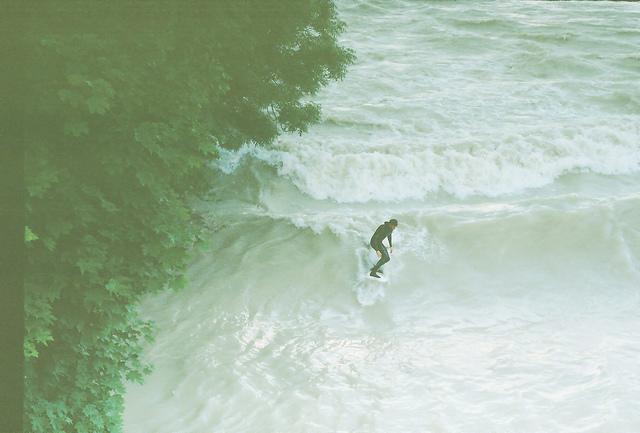What is the primary color in the photo?
Keep it brief. Green. How many people are on surfboards?
Answer briefly. 1. What activity is this person doing?
Answer briefly. Surfing. What is he standing on?
Give a very brief answer. Surfboard. 